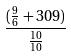Convert formula to latex. <formula><loc_0><loc_0><loc_500><loc_500>\frac { ( \frac { 9 } { 6 } + 3 0 9 ) } { \frac { 1 0 } { 1 0 } }</formula> 